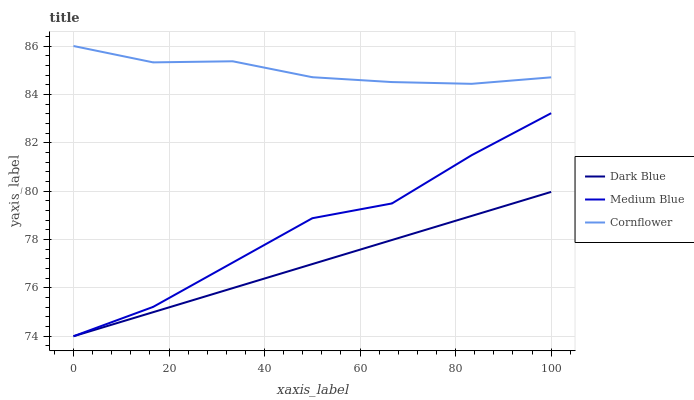Does Dark Blue have the minimum area under the curve?
Answer yes or no. Yes. Does Cornflower have the maximum area under the curve?
Answer yes or no. Yes. Does Medium Blue have the minimum area under the curve?
Answer yes or no. No. Does Medium Blue have the maximum area under the curve?
Answer yes or no. No. Is Dark Blue the smoothest?
Answer yes or no. Yes. Is Medium Blue the roughest?
Answer yes or no. Yes. Is Cornflower the smoothest?
Answer yes or no. No. Is Cornflower the roughest?
Answer yes or no. No. Does Dark Blue have the lowest value?
Answer yes or no. Yes. Does Cornflower have the lowest value?
Answer yes or no. No. Does Cornflower have the highest value?
Answer yes or no. Yes. Does Medium Blue have the highest value?
Answer yes or no. No. Is Dark Blue less than Cornflower?
Answer yes or no. Yes. Is Cornflower greater than Medium Blue?
Answer yes or no. Yes. Does Medium Blue intersect Dark Blue?
Answer yes or no. Yes. Is Medium Blue less than Dark Blue?
Answer yes or no. No. Is Medium Blue greater than Dark Blue?
Answer yes or no. No. Does Dark Blue intersect Cornflower?
Answer yes or no. No. 